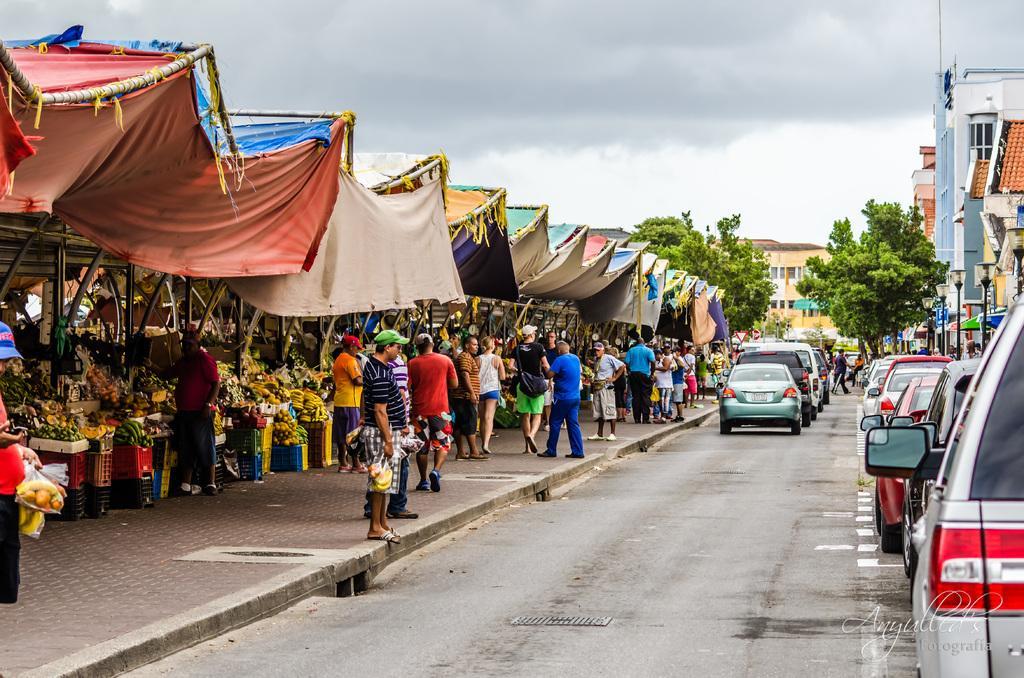How would you summarize this image in a sentence or two? In this image, there are a few people, buildings, trees, vehicles, tents. We can also see some baskets with objects like fruits. We can see the ground and the sky with clouds. We can also see some text on the bottom right corner. 